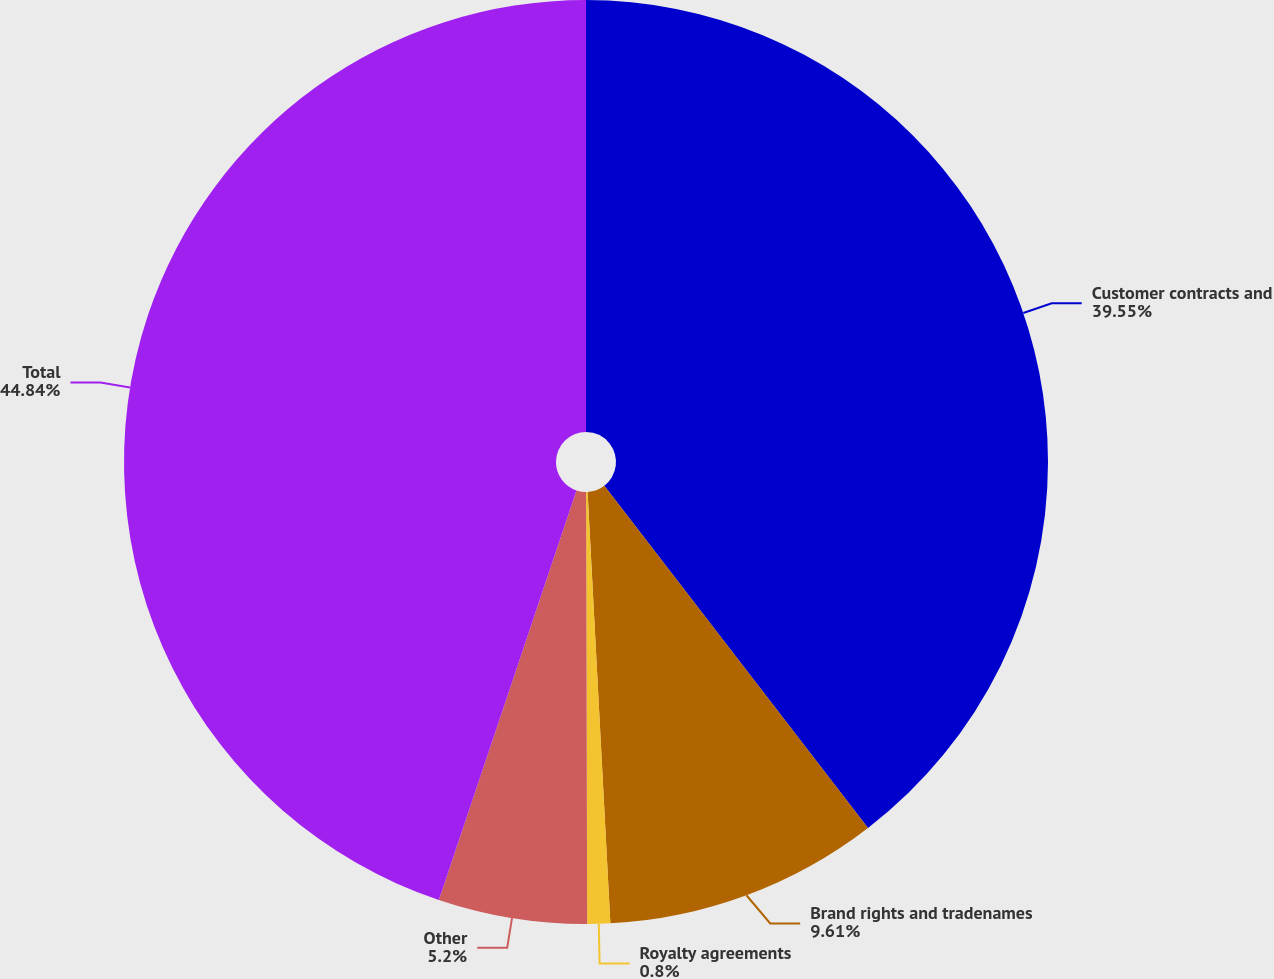Convert chart to OTSL. <chart><loc_0><loc_0><loc_500><loc_500><pie_chart><fcel>Customer contracts and<fcel>Brand rights and tradenames<fcel>Royalty agreements<fcel>Other<fcel>Total<nl><fcel>39.55%<fcel>9.61%<fcel>0.8%<fcel>5.2%<fcel>44.84%<nl></chart> 